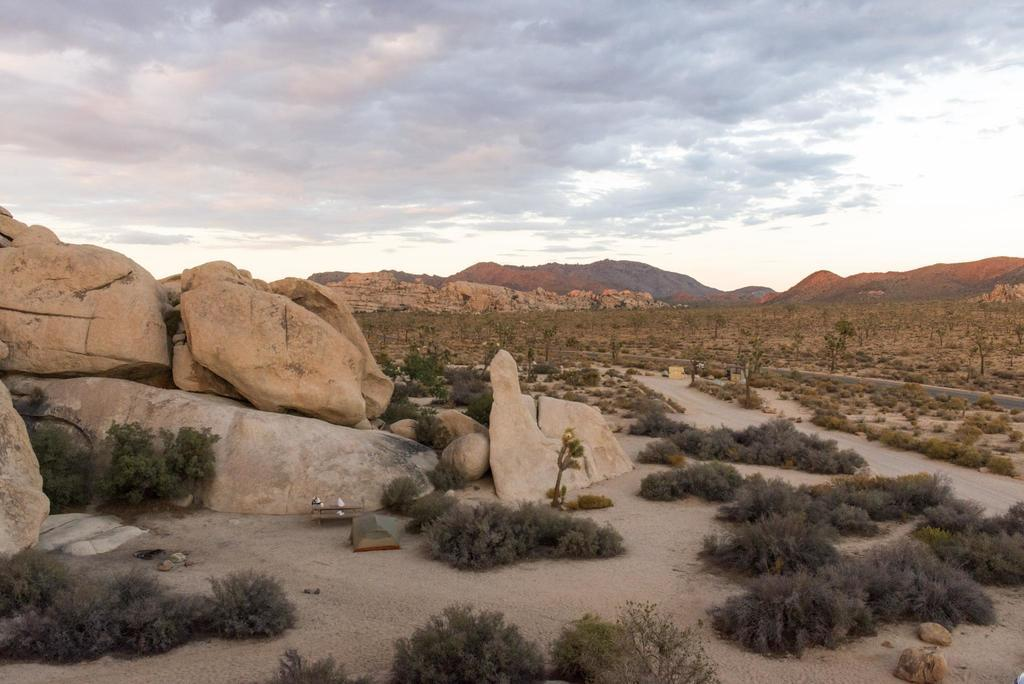What type of natural features can be seen in the image? There are rocks, trees, plants, and mountains in the image. What is visible in the background of the image? The sky is visible in the background of the image. What can be seen in the sky? Clouds are present in the sky. What type of cup is being used to carry the thing in the carriage in the image? There is no cup, thing, or carriage present in the image. 